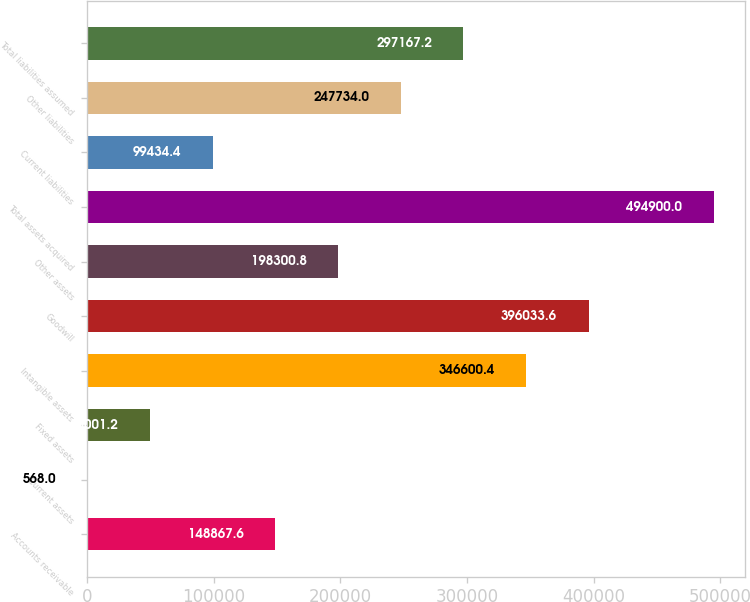Convert chart to OTSL. <chart><loc_0><loc_0><loc_500><loc_500><bar_chart><fcel>Accounts receivable<fcel>Current assets<fcel>Fixed assets<fcel>Intangible assets<fcel>Goodwill<fcel>Other assets<fcel>Total assets acquired<fcel>Current liabilities<fcel>Other liabilities<fcel>Total liabilities assumed<nl><fcel>148868<fcel>568<fcel>50001.2<fcel>346600<fcel>396034<fcel>198301<fcel>494900<fcel>99434.4<fcel>247734<fcel>297167<nl></chart> 